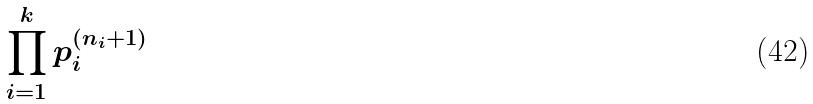<formula> <loc_0><loc_0><loc_500><loc_500>\prod _ { i = 1 } ^ { k } p _ { i } ^ { ( n _ { i } + 1 ) }</formula> 